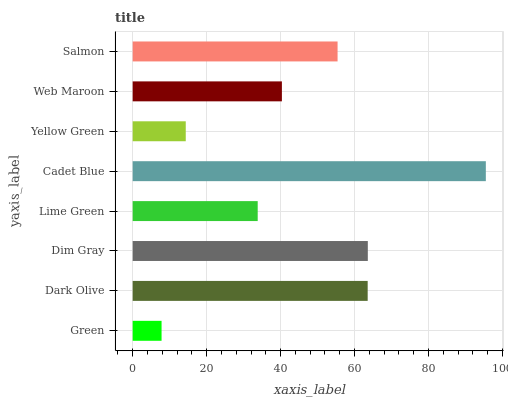Is Green the minimum?
Answer yes or no. Yes. Is Cadet Blue the maximum?
Answer yes or no. Yes. Is Dark Olive the minimum?
Answer yes or no. No. Is Dark Olive the maximum?
Answer yes or no. No. Is Dark Olive greater than Green?
Answer yes or no. Yes. Is Green less than Dark Olive?
Answer yes or no. Yes. Is Green greater than Dark Olive?
Answer yes or no. No. Is Dark Olive less than Green?
Answer yes or no. No. Is Salmon the high median?
Answer yes or no. Yes. Is Web Maroon the low median?
Answer yes or no. Yes. Is Web Maroon the high median?
Answer yes or no. No. Is Salmon the low median?
Answer yes or no. No. 